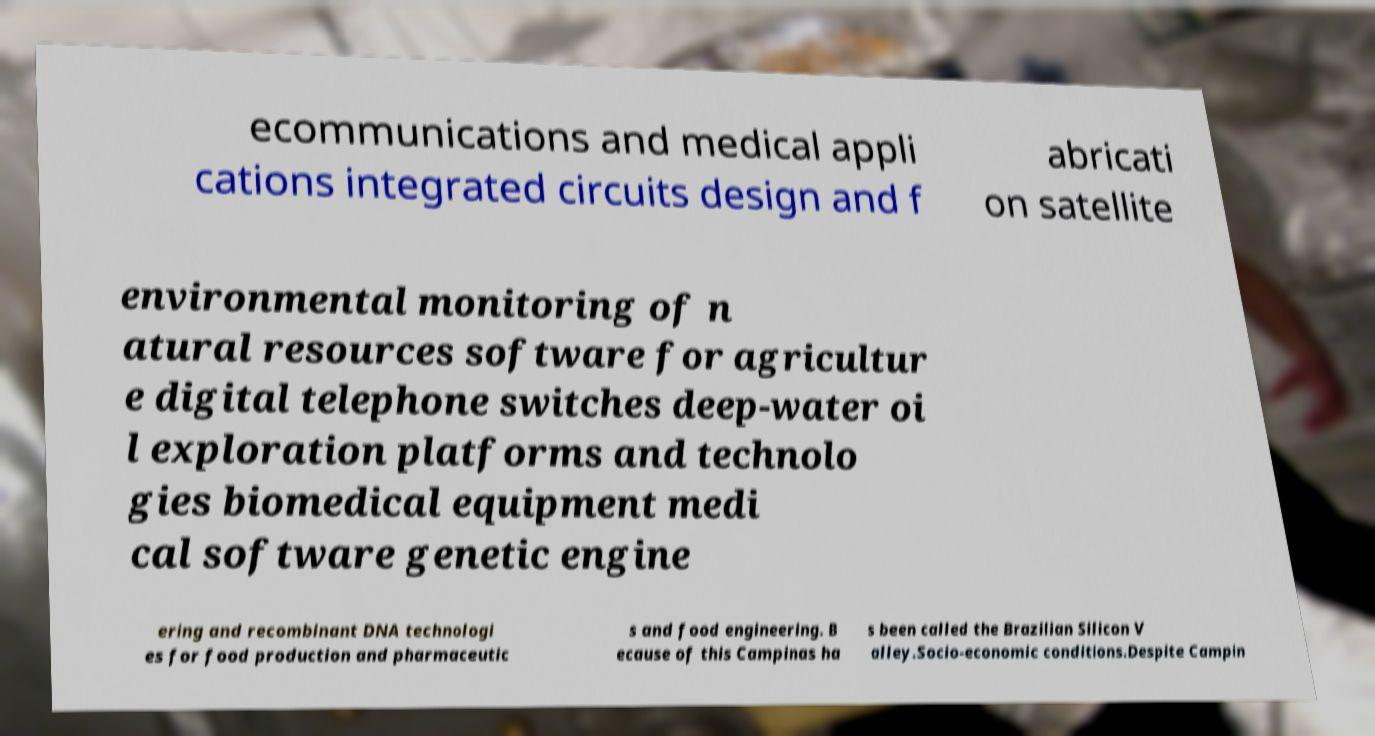What messages or text are displayed in this image? I need them in a readable, typed format. ecommunications and medical appli cations integrated circuits design and f abricati on satellite environmental monitoring of n atural resources software for agricultur e digital telephone switches deep-water oi l exploration platforms and technolo gies biomedical equipment medi cal software genetic engine ering and recombinant DNA technologi es for food production and pharmaceutic s and food engineering. B ecause of this Campinas ha s been called the Brazilian Silicon V alley.Socio-economic conditions.Despite Campin 